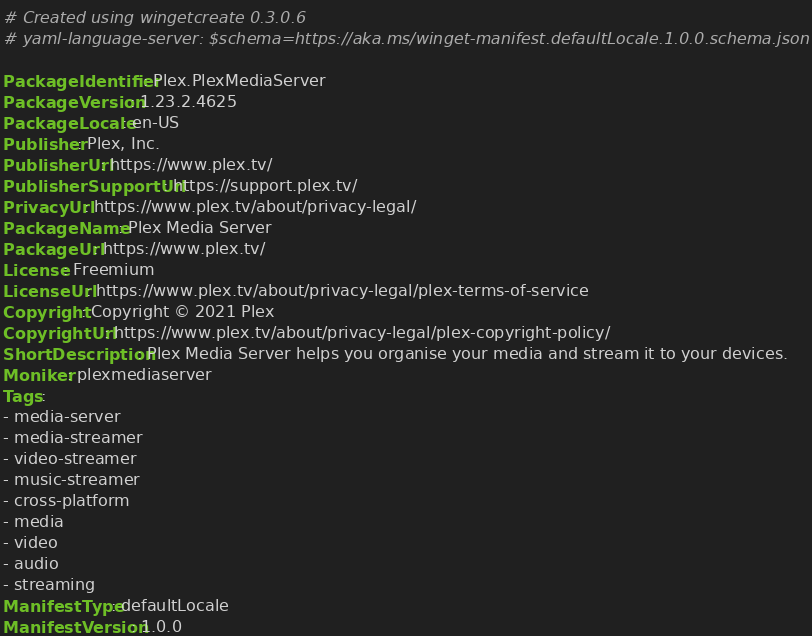<code> <loc_0><loc_0><loc_500><loc_500><_YAML_># Created using wingetcreate 0.3.0.6
# yaml-language-server: $schema=https://aka.ms/winget-manifest.defaultLocale.1.0.0.schema.json

PackageIdentifier: Plex.PlexMediaServer
PackageVersion: 1.23.2.4625
PackageLocale: en-US
Publisher: Plex, Inc.
PublisherUrl: https://www.plex.tv/
PublisherSupportUrl: https://support.plex.tv/
PrivacyUrl: https://www.plex.tv/about/privacy-legal/
PackageName: Plex Media Server
PackageUrl: https://www.plex.tv/
License: Freemium
LicenseUrl: https://www.plex.tv/about/privacy-legal/plex-terms-of-service
Copyright: Copyright © 2021 Plex
CopyrightUrl: https://www.plex.tv/about/privacy-legal/plex-copyright-policy/
ShortDescription: Plex Media Server helps you organise your media and stream it to your devices.
Moniker: plexmediaserver
Tags:
- media-server
- media-streamer
- video-streamer
- music-streamer
- cross-platform
- media
- video
- audio
- streaming
ManifestType: defaultLocale
ManifestVersion: 1.0.0

</code> 